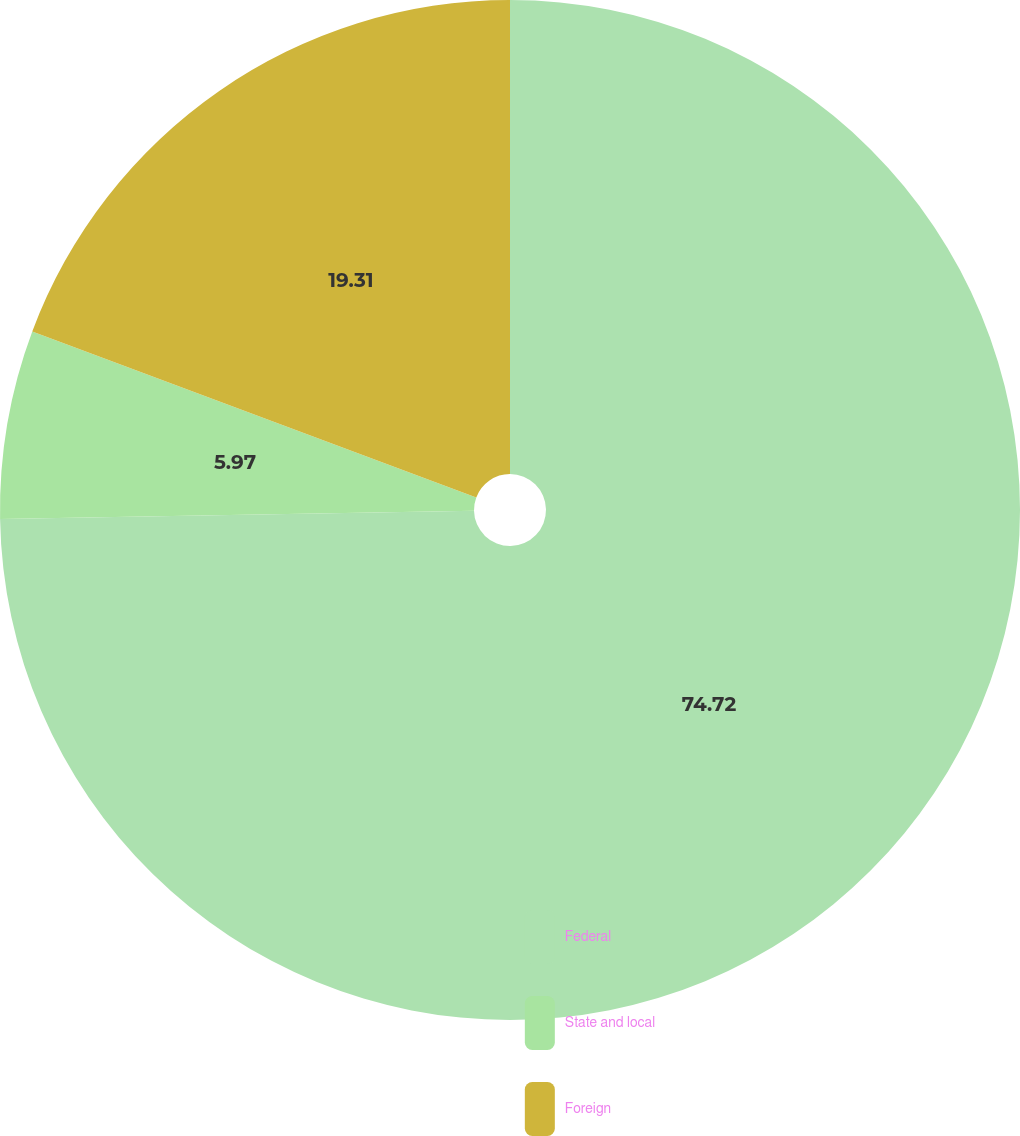Convert chart. <chart><loc_0><loc_0><loc_500><loc_500><pie_chart><fcel>Federal<fcel>State and local<fcel>Foreign<nl><fcel>74.73%<fcel>5.97%<fcel>19.31%<nl></chart> 